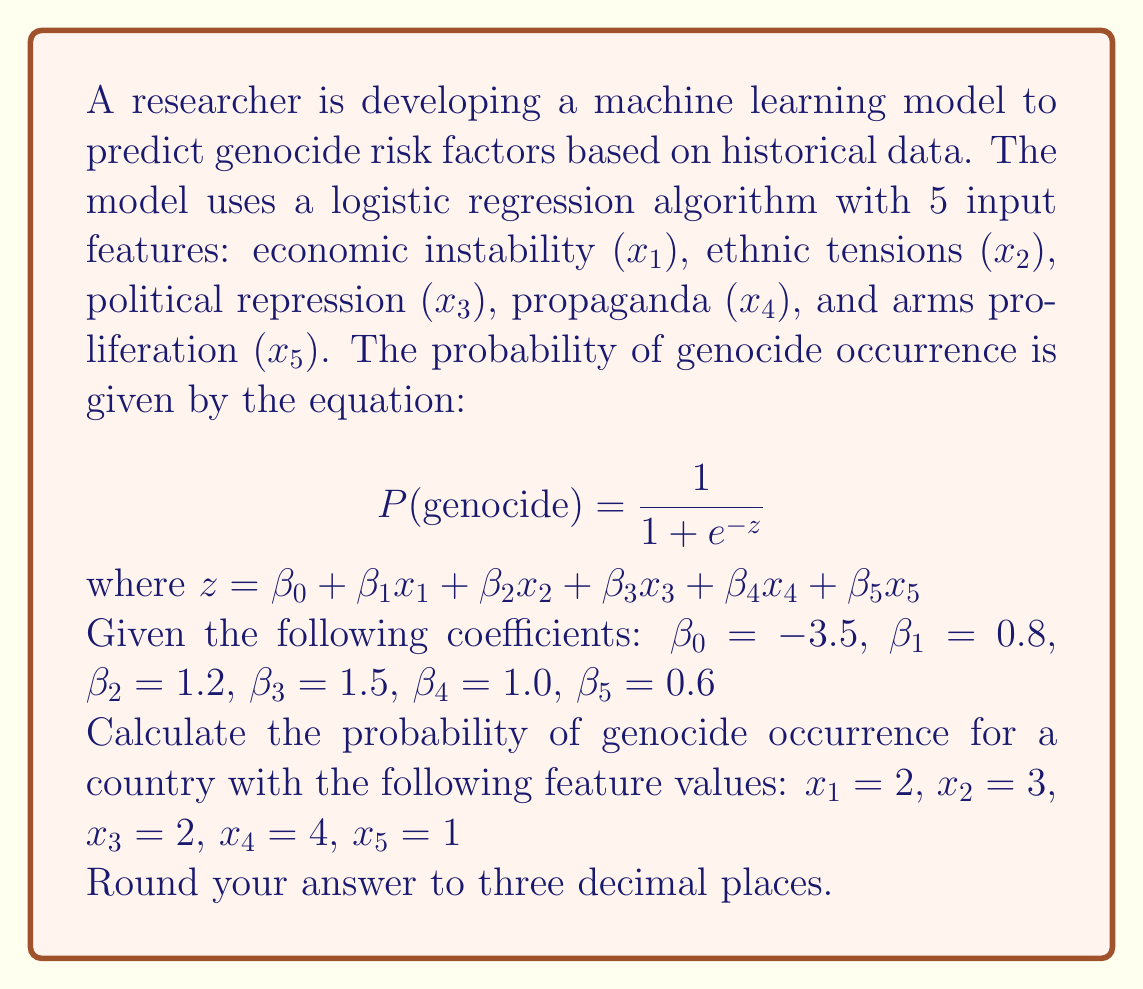Solve this math problem. To solve this problem, we'll follow these steps:

1. Calculate the value of $z$ using the given coefficients and feature values.
2. Use the logistic function to calculate the probability of genocide occurrence.
3. Round the result to three decimal places.

Step 1: Calculate $z$
$$ z = \beta_0 + \beta_1x_1 + \beta_2x_2 + \beta_3x_3 + \beta_4x_4 + \beta_5x_5 $$
$$ z = -3.5 + 0.8(2) + 1.2(3) + 1.5(2) + 1.0(4) + 0.6(1) $$
$$ z = -3.5 + 1.6 + 3.6 + 3.0 + 4.0 + 0.6 $$
$$ z = 9.3 $$

Step 2: Calculate the probability using the logistic function
$$ P(\text{genocide}) = \frac{1}{1 + e^{-z}} $$
$$ P(\text{genocide}) = \frac{1}{1 + e^{-9.3}} $$

Using a calculator or computer, we can evaluate this expression:
$$ P(\text{genocide}) \approx 0.9999088 $$

Step 3: Round to three decimal places
$$ P(\text{genocide}) \approx 1.000 $$

The probability of genocide occurrence, given the input features, is approximately 1.000 or 100%.
Answer: 1.000 